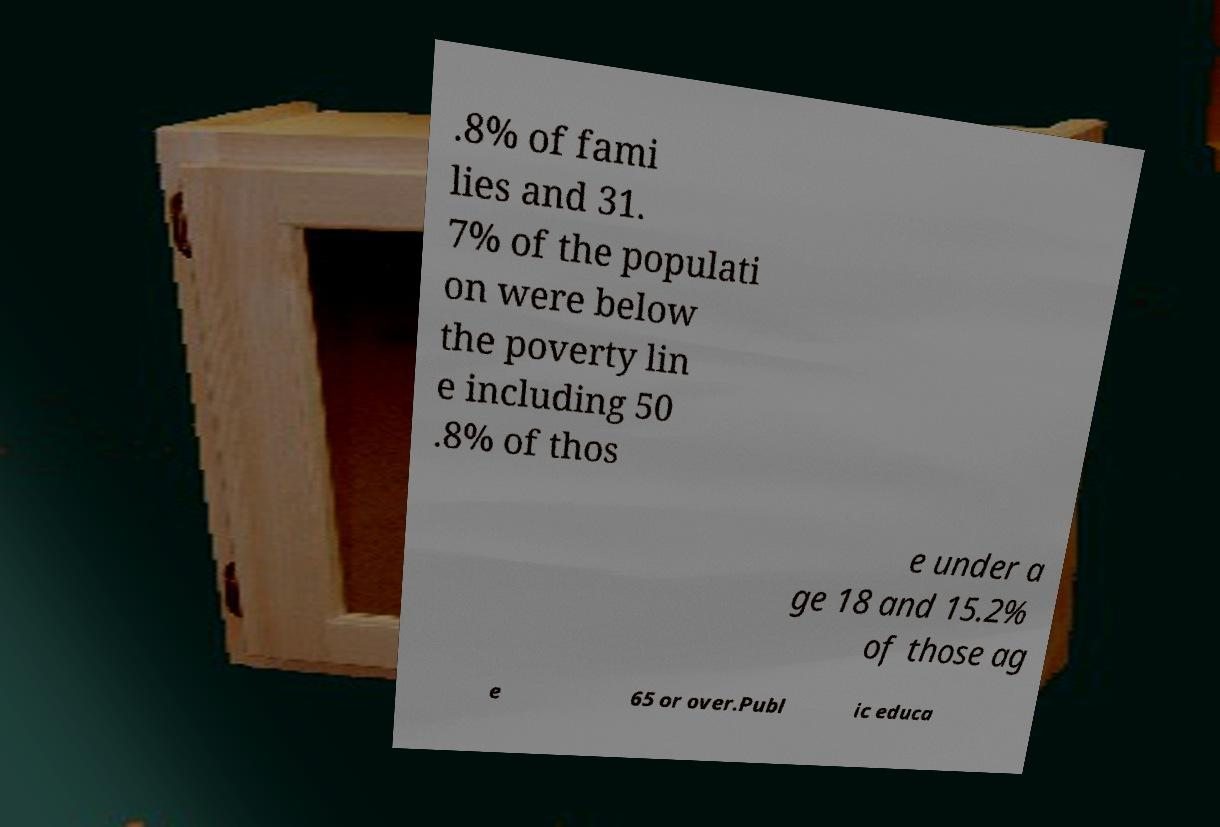I need the written content from this picture converted into text. Can you do that? .8% of fami lies and 31. 7% of the populati on were below the poverty lin e including 50 .8% of thos e under a ge 18 and 15.2% of those ag e 65 or over.Publ ic educa 